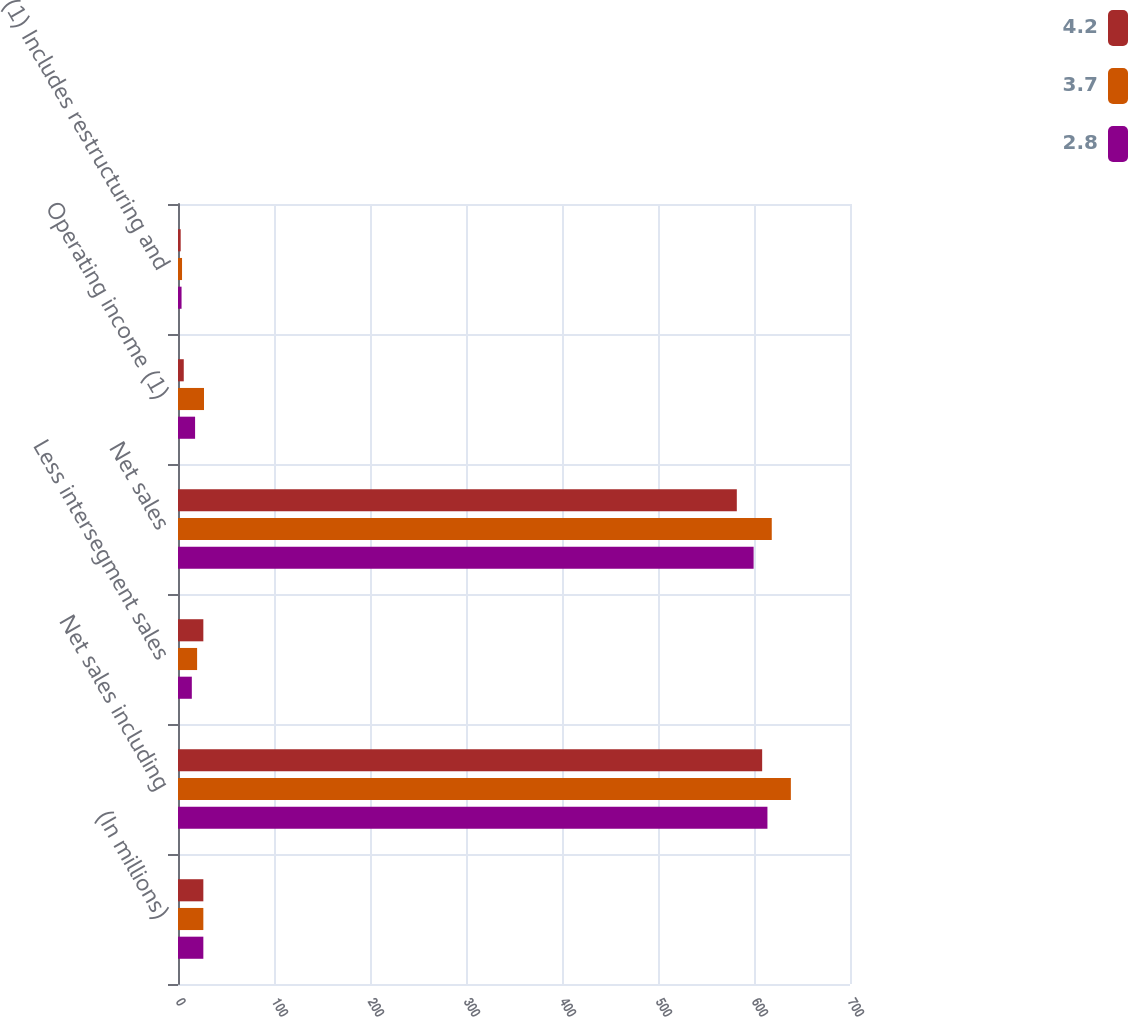<chart> <loc_0><loc_0><loc_500><loc_500><stacked_bar_chart><ecel><fcel>(In millions)<fcel>Net sales including<fcel>Less intersegment sales<fcel>Net sales<fcel>Operating income (1)<fcel>(1) Includes restructuring and<nl><fcel>4.2<fcel>26.4<fcel>608.5<fcel>26.4<fcel>582.1<fcel>6<fcel>2.8<nl><fcel>3.7<fcel>26.4<fcel>638.4<fcel>19.9<fcel>618.5<fcel>27.1<fcel>4.2<nl><fcel>2.8<fcel>26.4<fcel>614<fcel>14.4<fcel>599.6<fcel>17.8<fcel>3.7<nl></chart> 